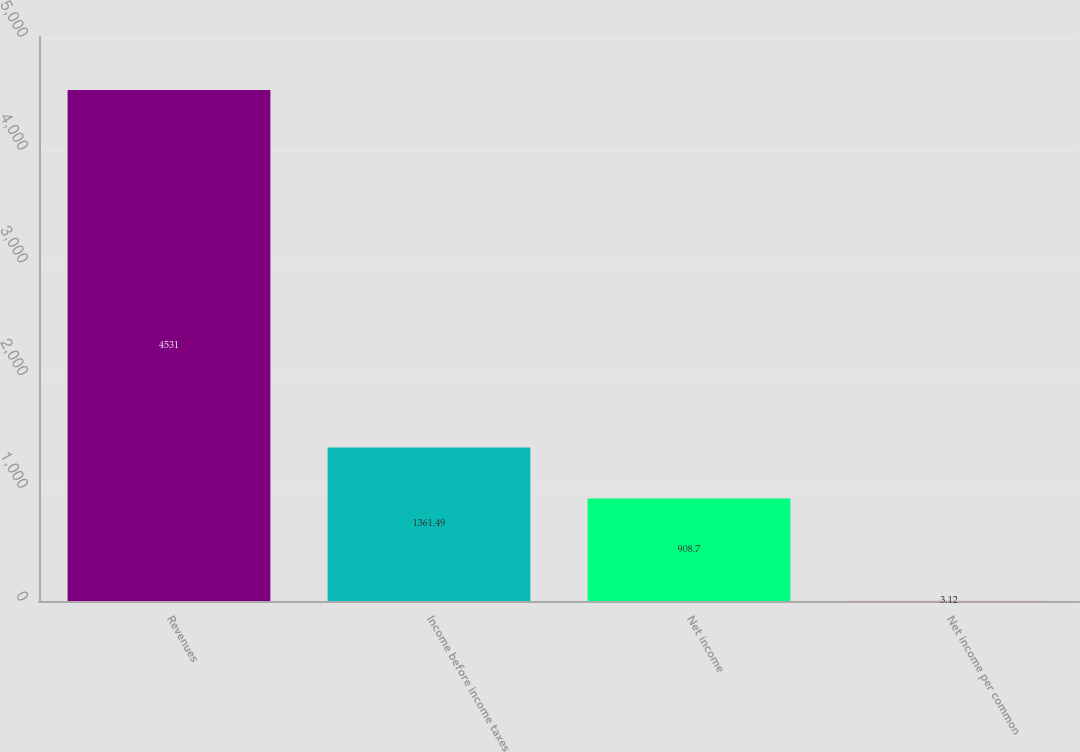Convert chart to OTSL. <chart><loc_0><loc_0><loc_500><loc_500><bar_chart><fcel>Revenues<fcel>Income before income taxes<fcel>Net income<fcel>Net income per common<nl><fcel>4531<fcel>1361.49<fcel>908.7<fcel>3.12<nl></chart> 